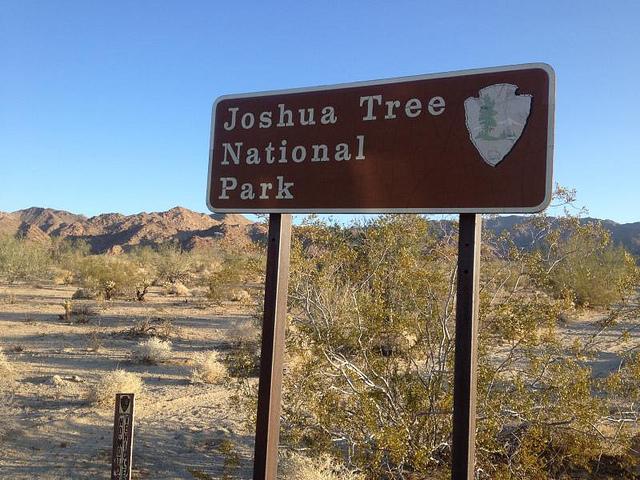Is the sign dirty?
Short answer required. No. What color is this sign?
Keep it brief. Brown. Why is the sign there?
Be succinct. Park. Is that a mobile home in the back?
Quick response, please. No. Is that a beach?
Short answer required. No. What type of plant is special in this park?
Quick response, please. Joshua tree. 